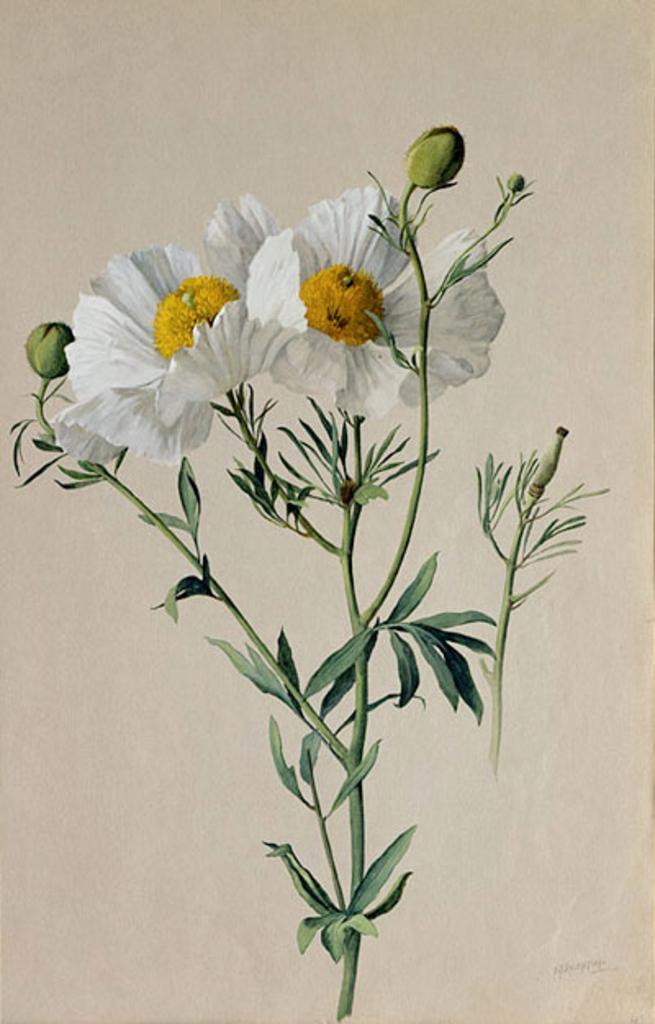What is the main subject of the image? There is a painting in the image. What is the painting on? The painting is on a white paper. What does the painting depict? The painting depicts a plant. How many white flowers are in the painting? There are two white flowers in the painting. What is the growth stage of the plant in the painting? There are buds on the plant in the painting. What type of pan is being used to cook the celery in the image? There is no pan or celery present in the image; it features a painting of a plant with white flowers and buds. 